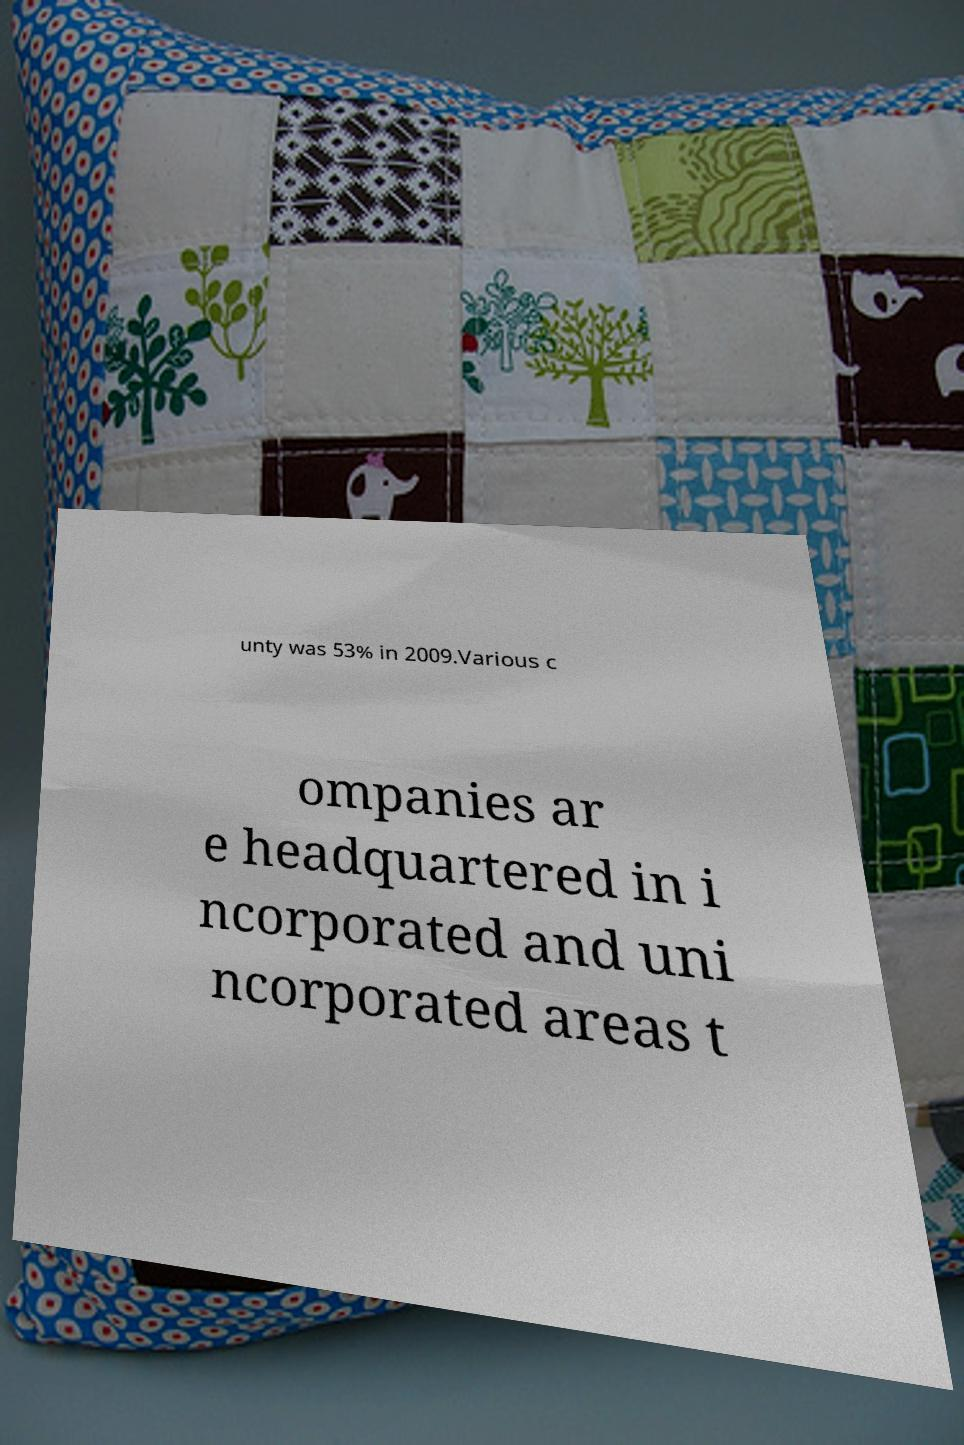Can you accurately transcribe the text from the provided image for me? unty was 53% in 2009.Various c ompanies ar e headquartered in i ncorporated and uni ncorporated areas t 